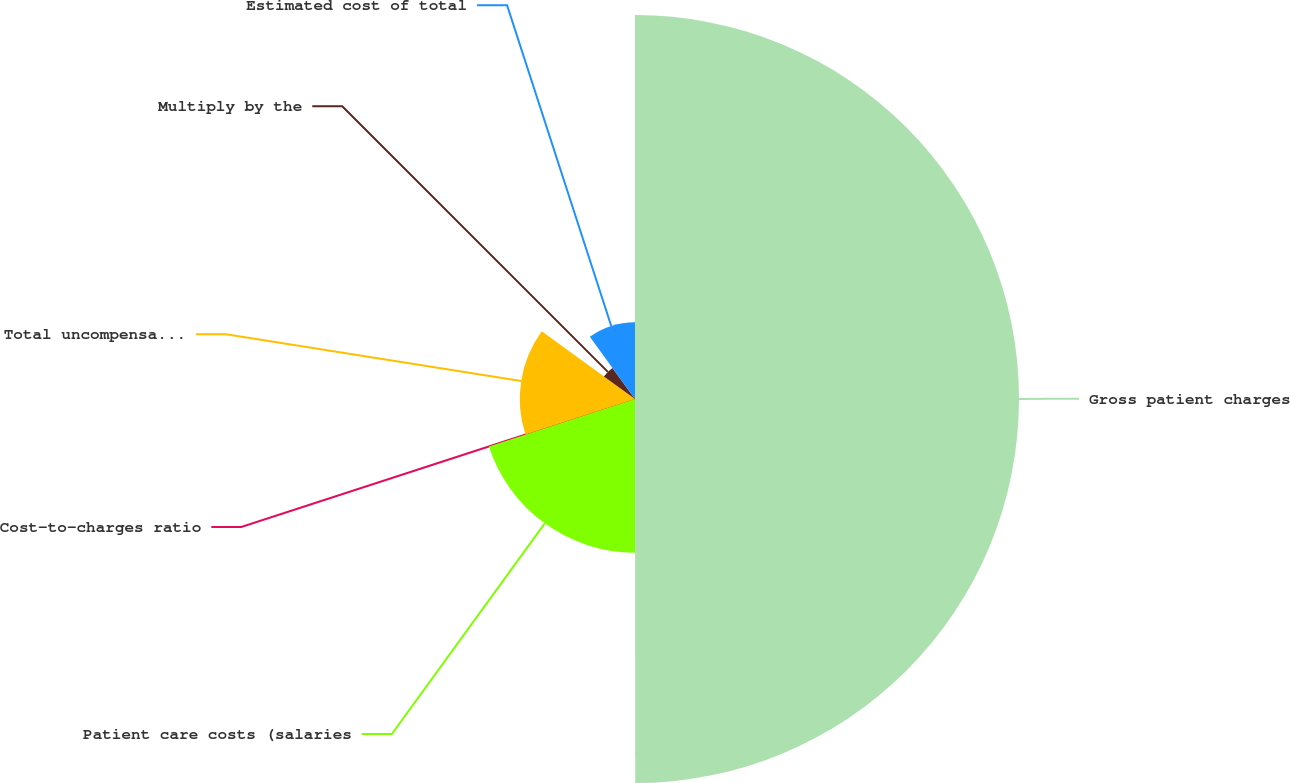<chart> <loc_0><loc_0><loc_500><loc_500><pie_chart><fcel>Gross patient charges<fcel>Patient care costs (salaries<fcel>Cost-to-charges ratio<fcel>Total uncompensated care<fcel>Multiply by the<fcel>Estimated cost of total<nl><fcel>49.99%<fcel>20.0%<fcel>0.01%<fcel>15.0%<fcel>5.0%<fcel>10.0%<nl></chart> 